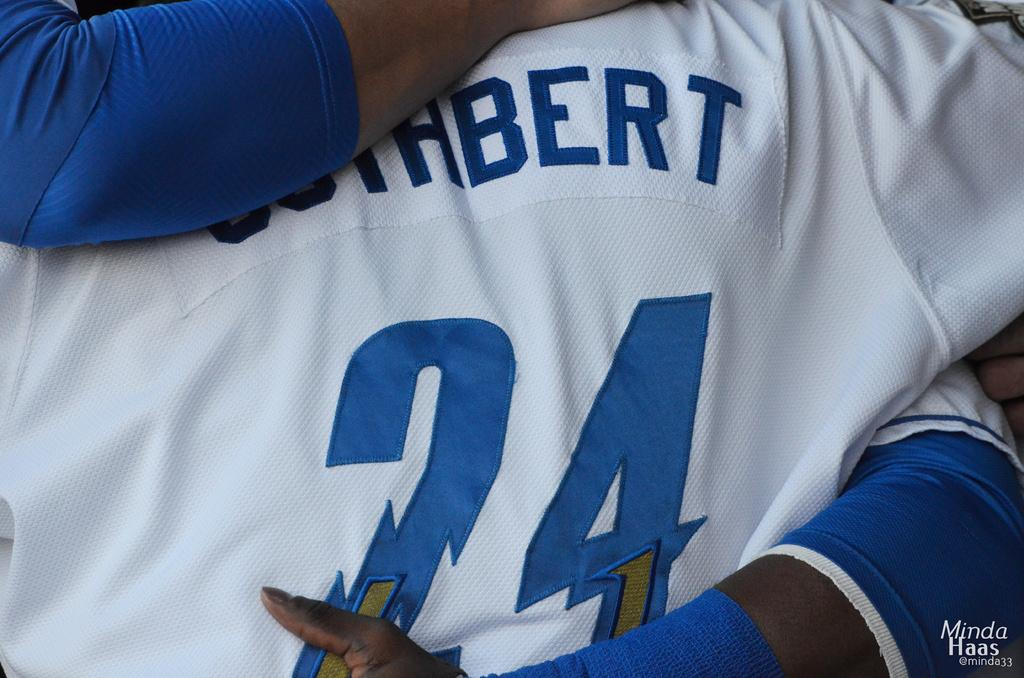<image>
Give a short and clear explanation of the subsequent image. Person wearing a jersey number 24 is getting a hug. 